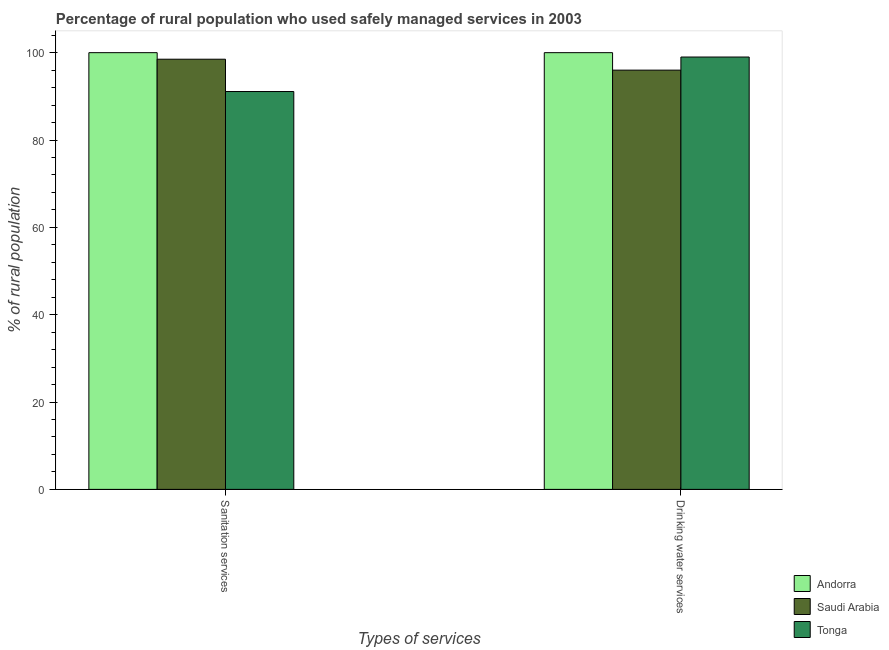How many bars are there on the 2nd tick from the left?
Make the answer very short. 3. How many bars are there on the 2nd tick from the right?
Your response must be concise. 3. What is the label of the 1st group of bars from the left?
Your answer should be compact. Sanitation services. What is the percentage of rural population who used sanitation services in Andorra?
Your answer should be compact. 100. Across all countries, what is the minimum percentage of rural population who used sanitation services?
Your response must be concise. 91.1. In which country was the percentage of rural population who used drinking water services maximum?
Make the answer very short. Andorra. In which country was the percentage of rural population who used drinking water services minimum?
Give a very brief answer. Saudi Arabia. What is the total percentage of rural population who used drinking water services in the graph?
Your answer should be compact. 295. What is the difference between the percentage of rural population who used sanitation services in Andorra and that in Tonga?
Your answer should be compact. 8.9. What is the difference between the percentage of rural population who used drinking water services in Andorra and the percentage of rural population who used sanitation services in Saudi Arabia?
Offer a terse response. 1.5. What is the average percentage of rural population who used drinking water services per country?
Ensure brevity in your answer.  98.33. What is the difference between the percentage of rural population who used sanitation services and percentage of rural population who used drinking water services in Andorra?
Your response must be concise. 0. What does the 3rd bar from the left in Drinking water services represents?
Your answer should be very brief. Tonga. What does the 3rd bar from the right in Drinking water services represents?
Keep it short and to the point. Andorra. Are all the bars in the graph horizontal?
Provide a short and direct response. No. What is the difference between two consecutive major ticks on the Y-axis?
Ensure brevity in your answer.  20. Are the values on the major ticks of Y-axis written in scientific E-notation?
Your answer should be compact. No. How many legend labels are there?
Provide a succinct answer. 3. How are the legend labels stacked?
Keep it short and to the point. Vertical. What is the title of the graph?
Offer a terse response. Percentage of rural population who used safely managed services in 2003. What is the label or title of the X-axis?
Your answer should be very brief. Types of services. What is the label or title of the Y-axis?
Ensure brevity in your answer.  % of rural population. What is the % of rural population of Andorra in Sanitation services?
Provide a short and direct response. 100. What is the % of rural population in Saudi Arabia in Sanitation services?
Keep it short and to the point. 98.5. What is the % of rural population of Tonga in Sanitation services?
Your response must be concise. 91.1. What is the % of rural population of Andorra in Drinking water services?
Your response must be concise. 100. What is the % of rural population in Saudi Arabia in Drinking water services?
Your response must be concise. 96. What is the % of rural population in Tonga in Drinking water services?
Your answer should be very brief. 99. Across all Types of services, what is the maximum % of rural population of Andorra?
Your response must be concise. 100. Across all Types of services, what is the maximum % of rural population of Saudi Arabia?
Ensure brevity in your answer.  98.5. Across all Types of services, what is the minimum % of rural population in Saudi Arabia?
Offer a very short reply. 96. Across all Types of services, what is the minimum % of rural population of Tonga?
Keep it short and to the point. 91.1. What is the total % of rural population of Saudi Arabia in the graph?
Your answer should be compact. 194.5. What is the total % of rural population in Tonga in the graph?
Offer a terse response. 190.1. What is the difference between the % of rural population in Andorra in Sanitation services and that in Drinking water services?
Make the answer very short. 0. What is the difference between the % of rural population of Saudi Arabia in Sanitation services and that in Drinking water services?
Your answer should be compact. 2.5. What is the difference between the % of rural population of Tonga in Sanitation services and that in Drinking water services?
Your answer should be very brief. -7.9. What is the average % of rural population in Saudi Arabia per Types of services?
Offer a very short reply. 97.25. What is the average % of rural population in Tonga per Types of services?
Your answer should be compact. 95.05. What is the difference between the % of rural population in Andorra and % of rural population in Saudi Arabia in Sanitation services?
Ensure brevity in your answer.  1.5. What is the difference between the % of rural population in Saudi Arabia and % of rural population in Tonga in Sanitation services?
Give a very brief answer. 7.4. What is the ratio of the % of rural population in Saudi Arabia in Sanitation services to that in Drinking water services?
Provide a succinct answer. 1.03. What is the ratio of the % of rural population in Tonga in Sanitation services to that in Drinking water services?
Your response must be concise. 0.92. What is the difference between the highest and the lowest % of rural population of Tonga?
Make the answer very short. 7.9. 